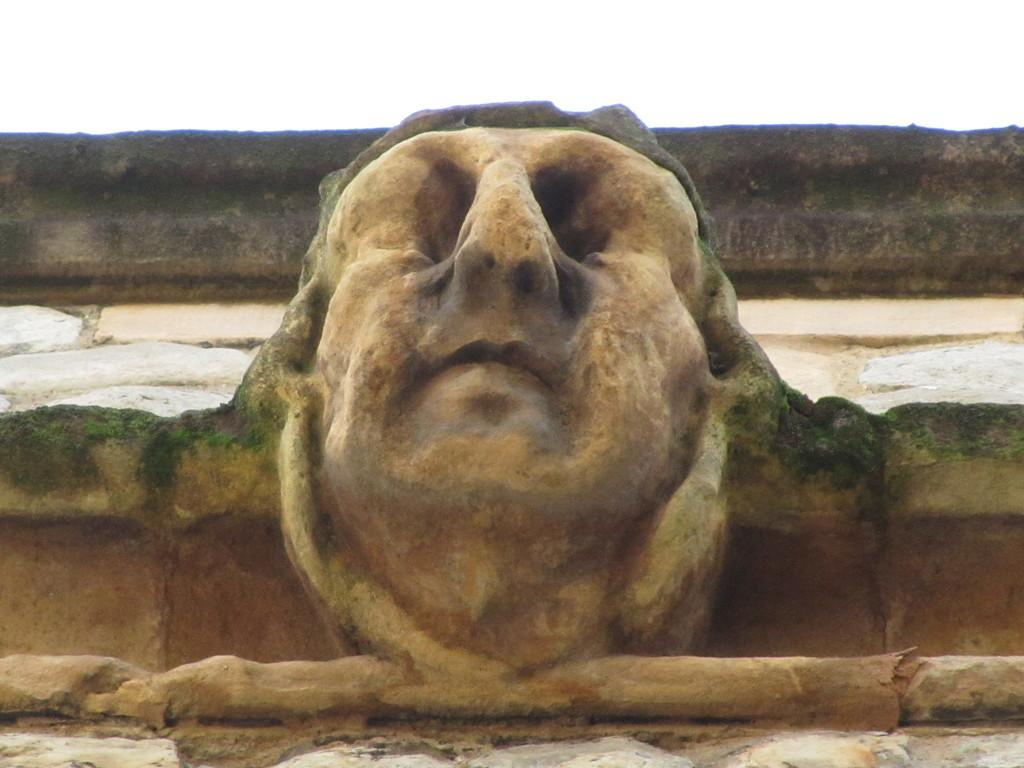What type of structure is present in the image? There is a rock structure in the image. What can be seen in the background of the image? There is a wall in the background of the image. What type of teaching method is being used by the stick in the image? There is no stick present in the image, and therefore no teaching method can be observed. 